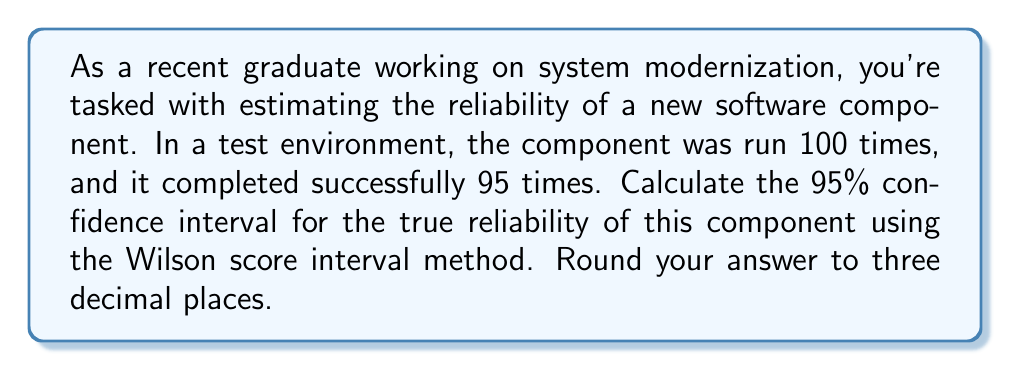Could you help me with this problem? To calculate the Wilson score interval for a 95% confidence level, we'll use the following formula:

$$ \frac{p + \frac{z^2}{2n} \pm z\sqrt{\frac{p(1-p)}{n} + \frac{z^2}{4n^2}}}{1 + \frac{z^2}{n}} $$

Where:
- $p$ is the observed proportion of successes
- $n$ is the sample size
- $z$ is the z-score for the desired confidence level (1.96 for 95% confidence)

Step 1: Calculate the observed proportion ($p$)
$p = \frac{95}{100} = 0.95$

Step 2: Determine the sample size ($n$) and z-score ($z$)
$n = 100$
$z = 1.96$ (for 95% confidence level)

Step 3: Calculate the center of the interval
$\text{Center} = \frac{p + \frac{z^2}{2n}}{1 + \frac{z^2}{n}} = \frac{0.95 + \frac{1.96^2}{2(100)}}{1 + \frac{1.96^2}{100}} = 0.9422$

Step 4: Calculate the margin of error
$\text{Margin of Error} = \frac{z\sqrt{\frac{p(1-p)}{n} + \frac{z^2}{4n^2}}}{1 + \frac{z^2}{n}} = \frac{1.96\sqrt{\frac{0.95(1-0.95)}{100} + \frac{1.96^2}{4(100^2)}}}{1 + \frac{1.96^2}{100}} = 0.0422$

Step 5: Calculate the lower and upper bounds of the confidence interval
Lower bound: $0.9422 - 0.0422 = 0.9000$
Upper bound: $0.9422 + 0.0422 = 0.9844$

Step 6: Round to three decimal places
Lower bound: $0.900$
Upper bound: $0.984$
Answer: (0.900, 0.984) 